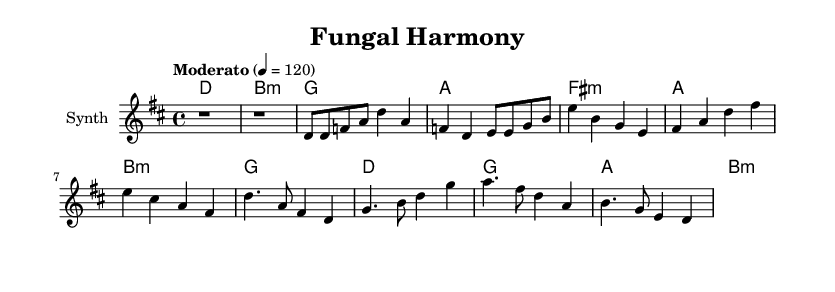What is the key signature of this music? The key signature is D major, which includes two sharps (F# and C#). This can be determined by identifying the key signature section in the music sheet and doing a knowledge check against common key signatures.
Answer: D major What is the time signature of this music? The time signature is 4/4, indicated at the beginning of the score. This means there are four beats per measure, with each quarter note receiving one beat.
Answer: 4/4 What is the tempo marking of this music? The tempo marking is "Moderato," which usually indicates a moderate speed, typically around 108-120 beats per minute. In this case, it specifically states "4 = 120," reinforcing this tempo.
Answer: Moderato What are the primary chords used in the verse? The primary chords used in the verse are D major, B minor, G major, and A major, which are indicated in the chord progression section of the sheet music.
Answer: D, B minor, G, A How many measures are there in the chorus section? There are four measures in the chorus section, as evidenced by the four sets of chord symbols and the corresponding melody notation, which follows the same structure.
Answer: 4 What thematic element do the lyrics represent? The lyrics represent the theme of "finding one's place in the world," which is a common motif in many K-Pop songs. This resonates with the nature-inspired sounds present in the melody.
Answer: Finding one's place in the world 